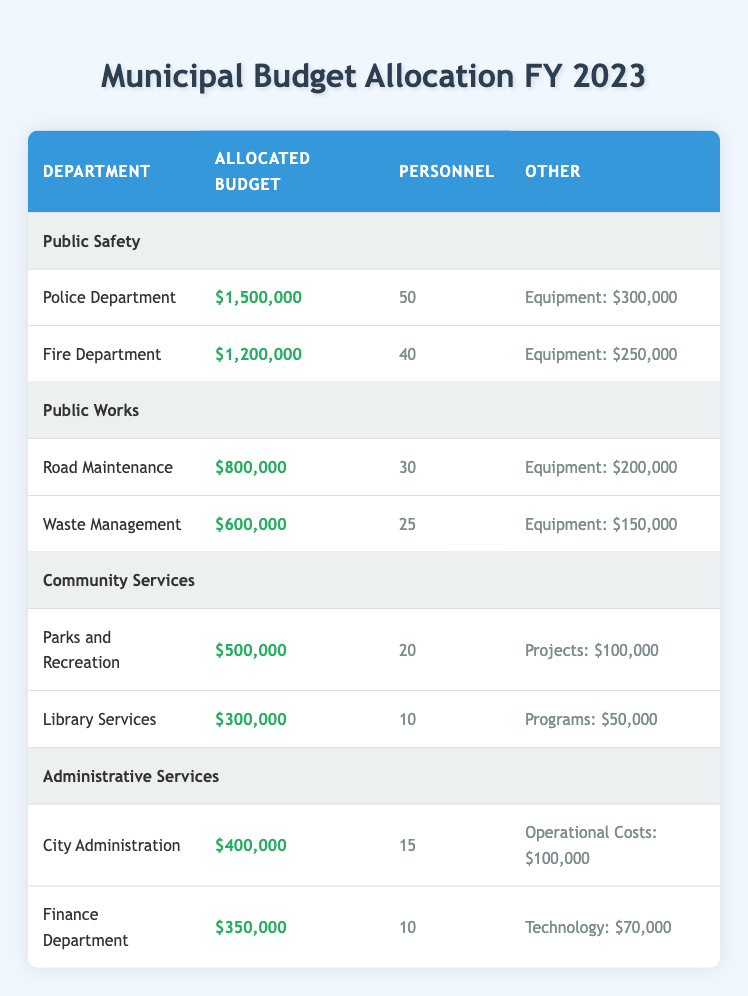What is the allocated budget for the Police Department? The Police Department is listed in the table under the Public Safety department. The allocated budget for the Police Department is clearly mentioned as $1,500,000.
Answer: $1,500,000 How many personnel are assigned to the Fire Department? To find this, we look under the Fire Department section in the Public Safety department. It states that there are 40 personnel assigned to this department.
Answer: 40 What is the total allocated budget for Community Services? The total allocated budget for Community Services includes the budgets for Parks and Recreation ($500,000) and Library Services ($300,000). Adding these together gives us $500,000 + $300,000 = $800,000.
Answer: $800,000 Is the Equipment budget for the Road Maintenance department more than that for the Waste Management department? The Equipment budget for Road Maintenance is $200,000, while Waste Management is $150,000. Since $200,000 is greater than $150,000, the statement is true.
Answer: Yes Which department has the highest number of personnel? To determine this, we need to look at the personnel numbers for each department. The Police Department has 50, the Fire Department has 40, Road Maintenance has 30, Waste Management has 25, Parks and Recreation has 20, and Library Services has 10. The Police Department has the highest personnel count with 50.
Answer: Police Department What is the average equipment budget across Public Safety and Public Works departments? First, we find the total equipment budget for both departments: Public Safety (300,000 for Police + 250,000 for Fire = 550,000) and Public Works (200,000 for Road Maintenance + 150,000 for Waste Management = 350,000). The total equipment budget is $550,000 + $350,000 = $900,000. There are 4 departments considered, so the average is $900,000 / 4 = $225,000.
Answer: $225,000 Does the Library Services department have a higher budget for programs than the Parks and Recreation department has for projects? Library Services has a programs budget of $50,000, while Parks and Recreation has a projects budget of $100,000. Since $50,000 is less than $100,000, the statement is false.
Answer: No How much budget is allocated for the Finance Department and City Administration combined? To find this total, we add the allocated budget for the Finance Department ($350,000) and the City Administration ($400,000). The summed total is $350,000 + $400,000 = $750,000.
Answer: $750,000 What percentage of the total budget does the Fire Department's budget represent if the total allocated budget across all departments is $5,250,000? First, we calculate the total budget, which is $5,250,000. The allocated budget for the Fire Department is $1,200,000. To find the percentage, divide $1,200,000 by $5,250,000 and multiply by 100: (1,200,000 / 5,250,000) * 100 = 22.86%.
Answer: 22.86% 